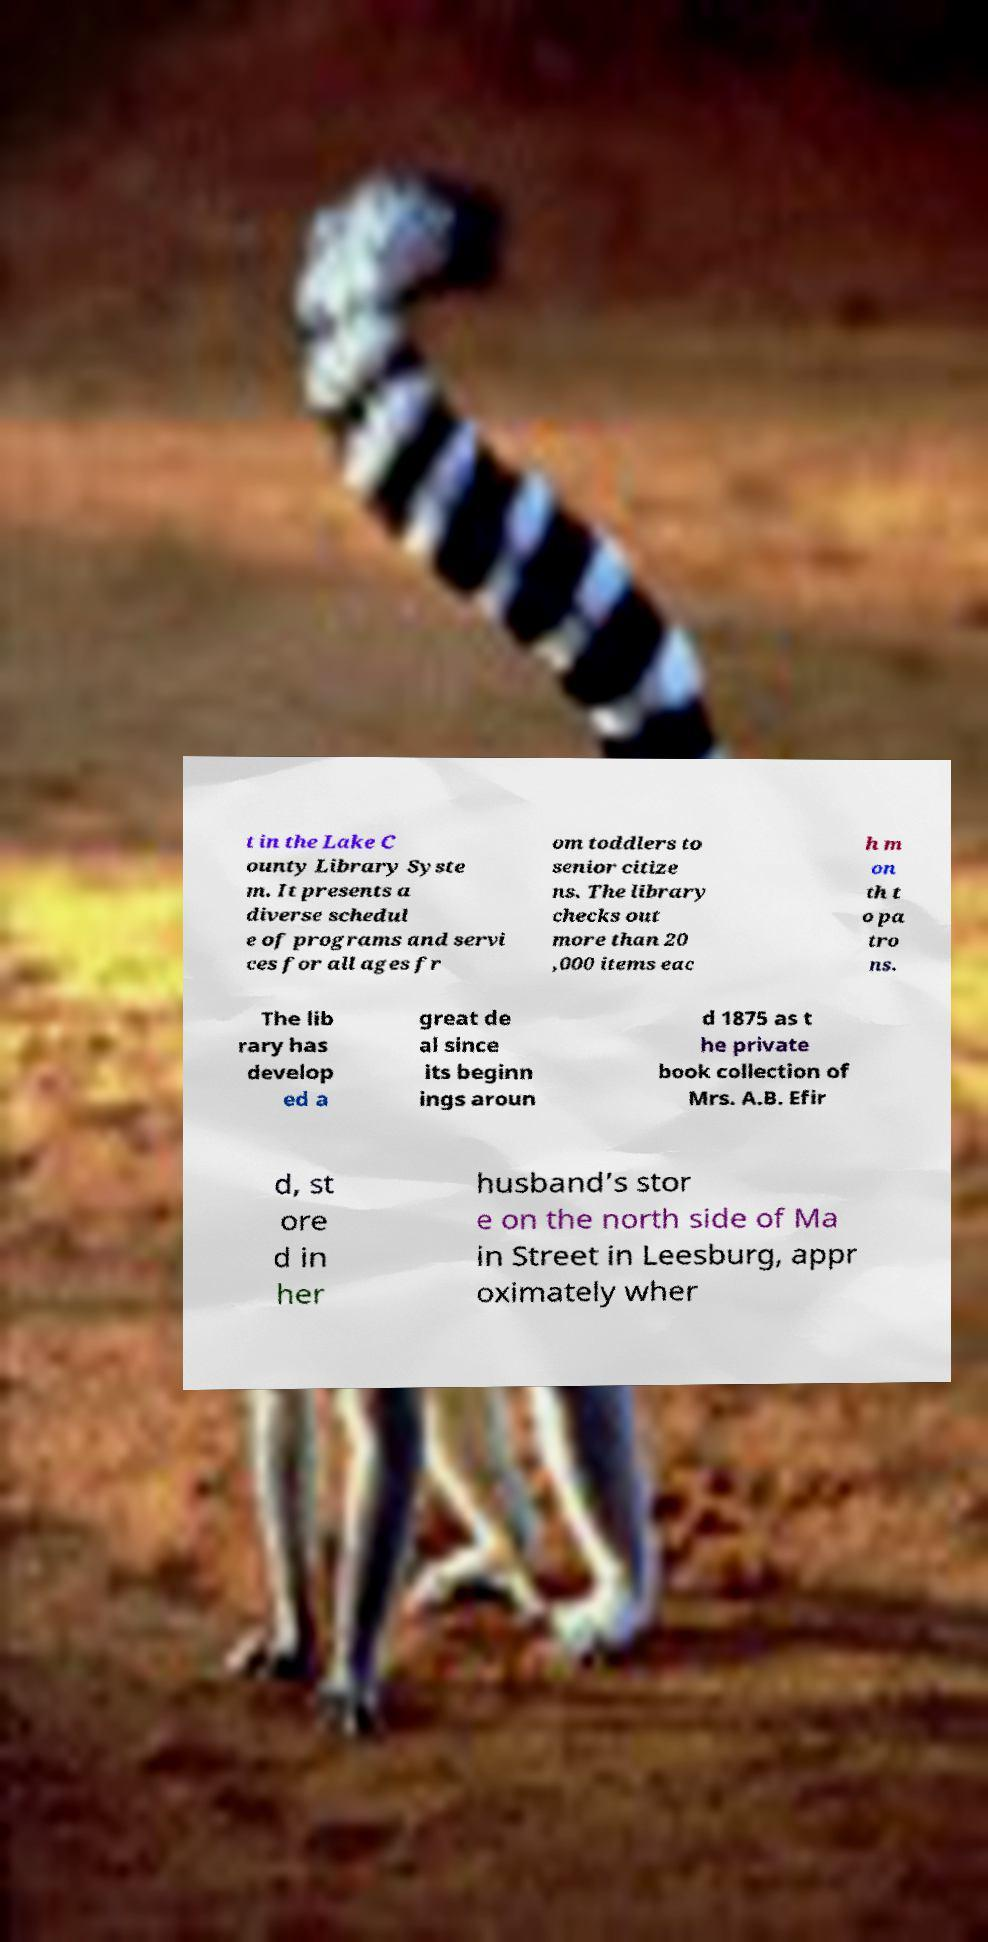Can you read and provide the text displayed in the image?This photo seems to have some interesting text. Can you extract and type it out for me? t in the Lake C ounty Library Syste m. It presents a diverse schedul e of programs and servi ces for all ages fr om toddlers to senior citize ns. The library checks out more than 20 ,000 items eac h m on th t o pa tro ns. The lib rary has develop ed a great de al since its beginn ings aroun d 1875 as t he private book collection of Mrs. A.B. Efir d, st ore d in her husband’s stor e on the north side of Ma in Street in Leesburg, appr oximately wher 